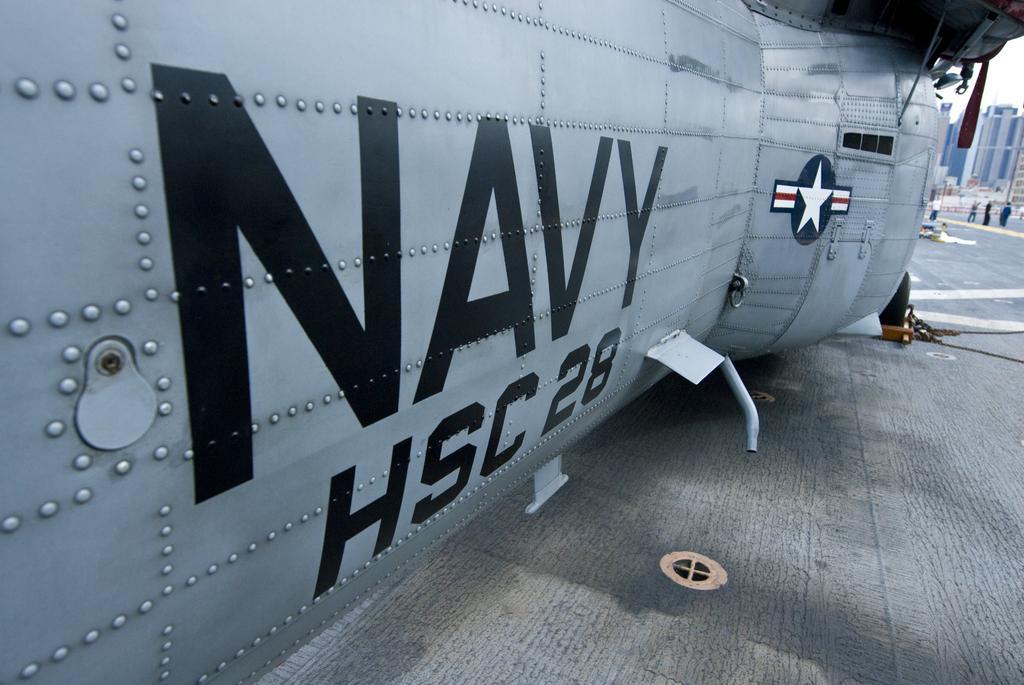Could you give a brief overview of what you see in this image? In this picture we can see some text, numbers and a star is visible on a metal object. There are a few objects visible on the path. We can see a few people and buildings in the background. 